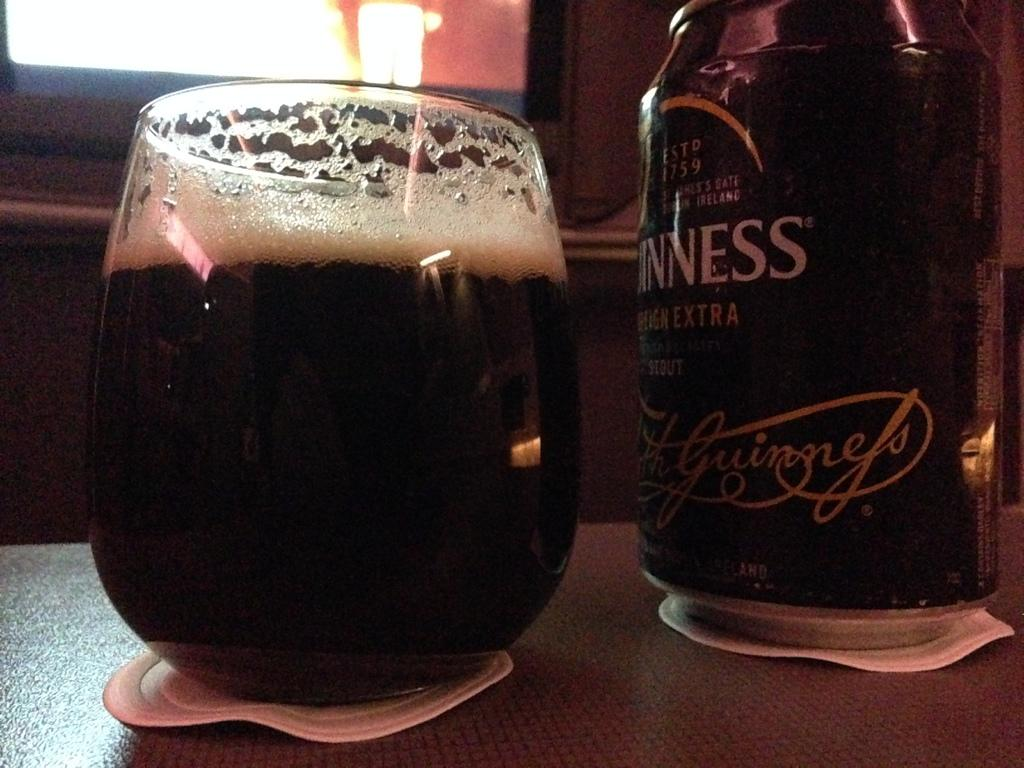Provide a one-sentence caption for the provided image. A glass filled with Guinness sits on a wooden table. 